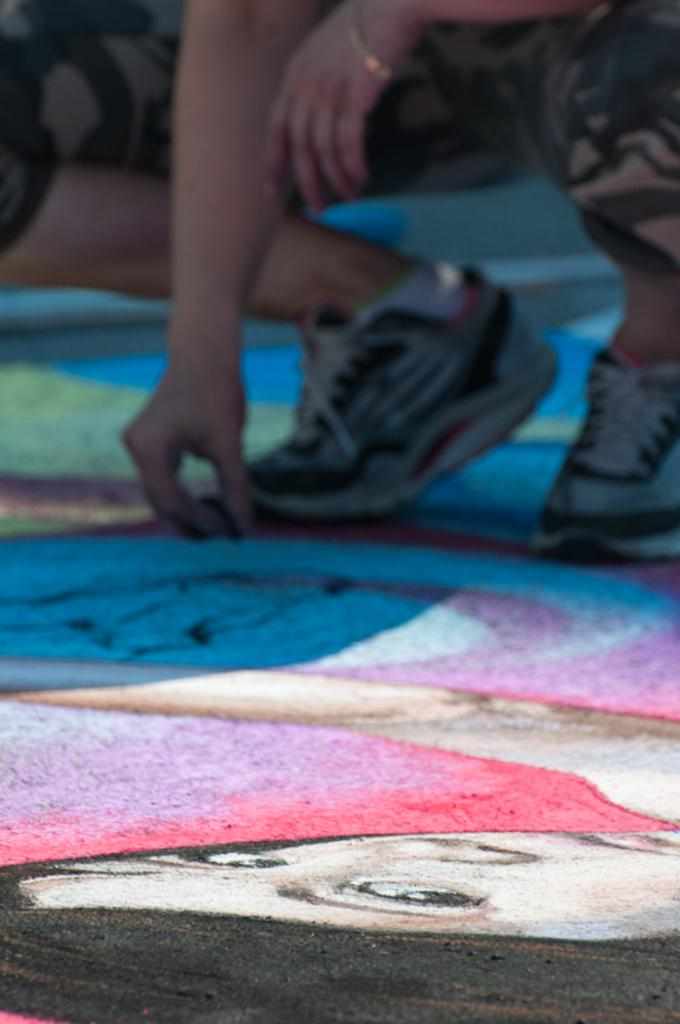What is placed on the floor in the image? There is a painting on the floor in the image. Can you describe the person in the center of the image? Unfortunately, the facts provided do not give any details about the person's appearance or actions. What type of lace can be seen on the zebra in the image? There is no zebra or lace present in the image. 